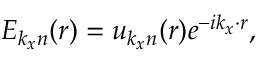<formula> <loc_0><loc_0><loc_500><loc_500>E _ { k _ { x } n } ( r ) = u _ { k _ { x } n } ( r ) e ^ { - i k _ { x } \cdot r } ,</formula> 